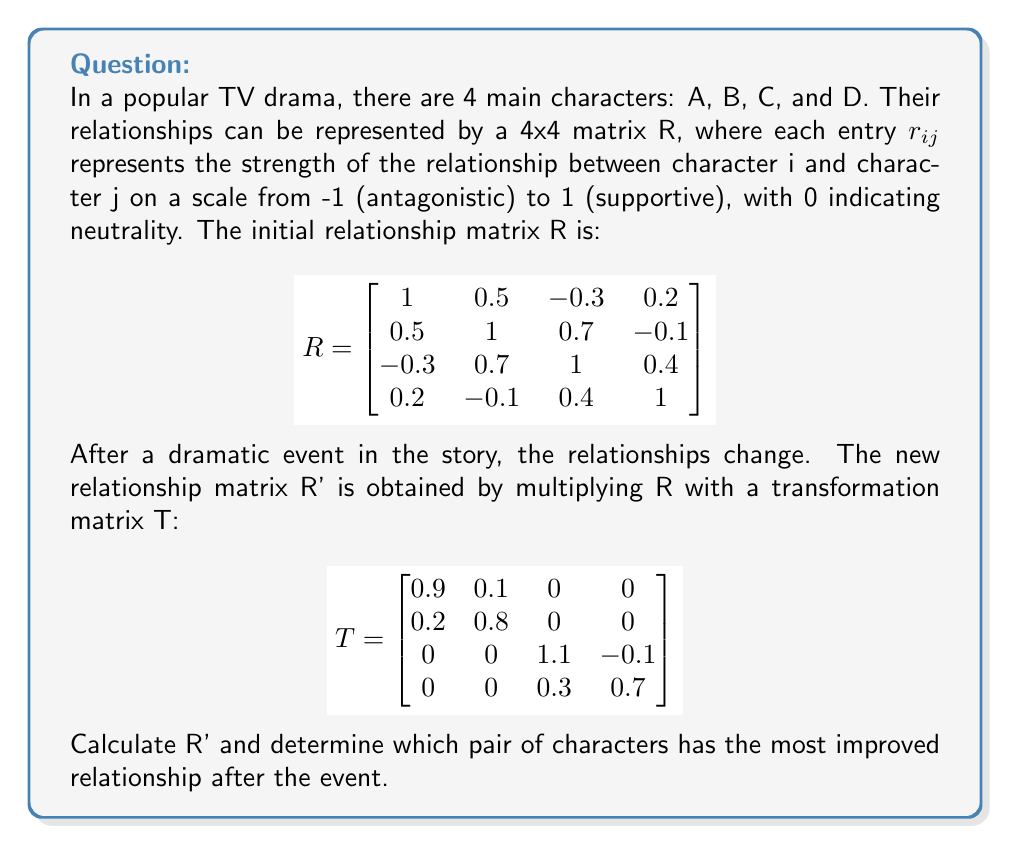Provide a solution to this math problem. To solve this problem, we need to follow these steps:

1) First, we need to multiply the matrices R and T to get R':
   
   R' = R × T

2) To multiply these 4x4 matrices, we use the standard matrix multiplication formula:
   
   $r'_{ij} = \sum_{k=1}^{4} r_{ik} \times t_{kj}$

3) Let's calculate R':

   $$R' = \begin{bmatrix}
   (1×0.9 + 0.5×0.2) & (1×0.1 + 0.5×0.8) & (-0.3×1.1 + 0.2×0.3) & (-0.3×-0.1 + 0.2×0.7)\\
   (0.5×0.9 + 1×0.2) & (0.5×0.1 + 1×0.8) & (0.7×1.1 + -0.1×0.3) & (0.7×-0.1 + -0.1×0.7)\\
   (-0.3×0.9 + 0.7×0.2) & (-0.3×0.1 + 0.7×0.8) & (1×1.1 + 0.4×0.3) & (1×-0.1 + 0.4×0.7)\\
   (0.2×0.9 + -0.1×0.2) & (0.2×0.1 + -0.1×0.8) & (0.4×1.1 + 1×0.3) & (0.4×-0.1 + 1×0.7)
   \end{bmatrix}$$

4) Simplifying:

   $$R' = \begin{bmatrix}
   1.0 & 0.5 & -0.27 & 0.17\\
   0.65 & 0.85 & 0.74 & -0.14\\
   -0.13 & 0.53 & 1.22 & 0.21\\
   0.16 & -0.06 & 0.74 & 0.67
   \end{bmatrix}$$

5) To find the most improved relationship, we need to compare each non-diagonal element in R' with its corresponding element in R and find the largest increase:

   A-B: 0.5 → 0.5 (no change)
   A-C: -0.3 → -0.27 (improved by 0.03)
   A-D: 0.2 → 0.17 (worsened by 0.03)
   B-C: 0.7 → 0.74 (improved by 0.04)
   B-D: -0.1 → -0.14 (worsened by 0.04)
   C-D: 0.4 → 0.74 (improved by 0.34)

6) The largest improvement is between characters C and D, with an increase of 0.34.
Answer: Characters C and D 